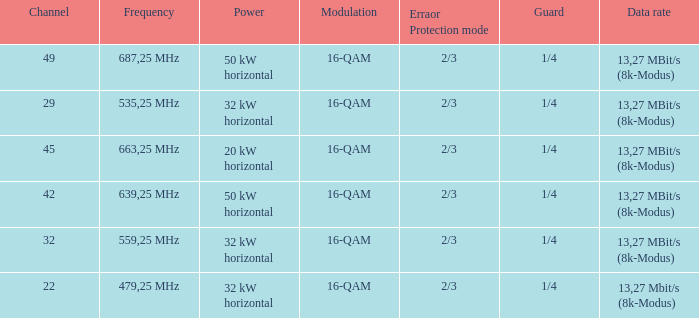On channel 32, when the power is 32 kW horizontal, what is the modulation? 16-QAM. 